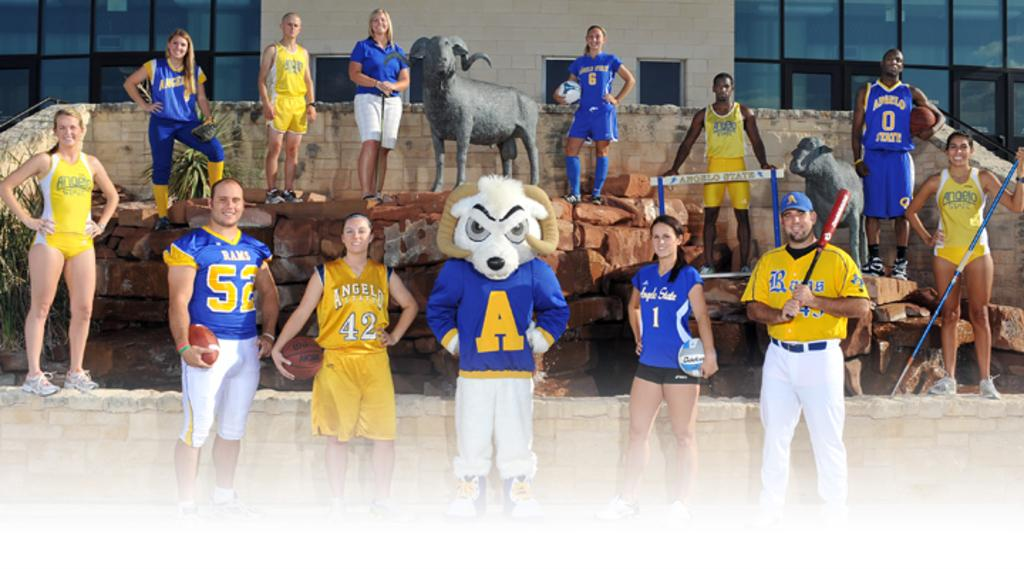<image>
Offer a succinct explanation of the picture presented. Athletes in blue and yellow costumes for various teams like the Rams and Angelo State 